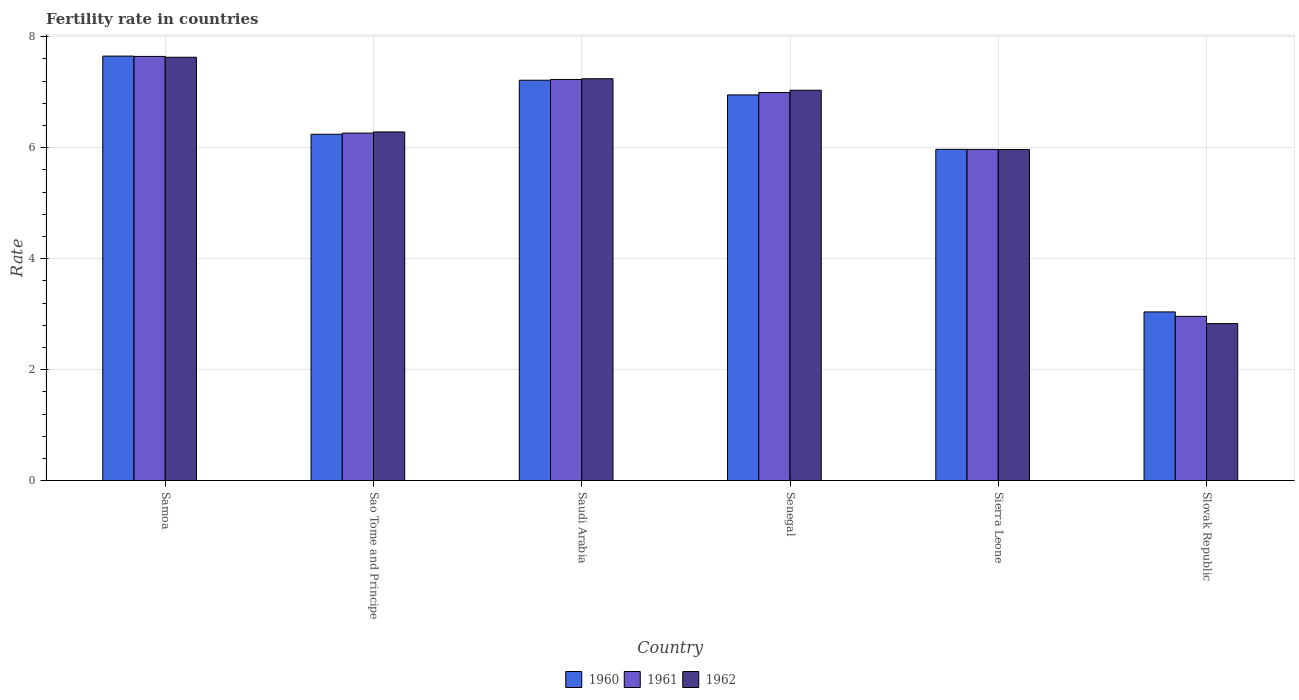Are the number of bars per tick equal to the number of legend labels?
Your answer should be very brief. Yes. Are the number of bars on each tick of the X-axis equal?
Give a very brief answer. Yes. How many bars are there on the 4th tick from the left?
Provide a short and direct response. 3. How many bars are there on the 3rd tick from the right?
Ensure brevity in your answer.  3. What is the label of the 2nd group of bars from the left?
Offer a terse response. Sao Tome and Principe. In how many cases, is the number of bars for a given country not equal to the number of legend labels?
Offer a very short reply. 0. What is the fertility rate in 1961 in Senegal?
Make the answer very short. 6.99. Across all countries, what is the maximum fertility rate in 1962?
Give a very brief answer. 7.63. Across all countries, what is the minimum fertility rate in 1960?
Offer a very short reply. 3.04. In which country was the fertility rate in 1960 maximum?
Your response must be concise. Samoa. In which country was the fertility rate in 1961 minimum?
Your response must be concise. Slovak Republic. What is the total fertility rate in 1962 in the graph?
Provide a succinct answer. 36.99. What is the difference between the fertility rate in 1961 in Saudi Arabia and that in Slovak Republic?
Make the answer very short. 4.27. What is the difference between the fertility rate in 1962 in Sierra Leone and the fertility rate in 1960 in Slovak Republic?
Your answer should be compact. 2.93. What is the average fertility rate in 1961 per country?
Provide a short and direct response. 6.18. What is the difference between the fertility rate of/in 1960 and fertility rate of/in 1962 in Senegal?
Make the answer very short. -0.08. What is the ratio of the fertility rate in 1961 in Sao Tome and Principe to that in Slovak Republic?
Your answer should be very brief. 2.12. What is the difference between the highest and the second highest fertility rate in 1960?
Your answer should be compact. 0.26. In how many countries, is the fertility rate in 1961 greater than the average fertility rate in 1961 taken over all countries?
Offer a terse response. 4. Is the sum of the fertility rate in 1960 in Samoa and Sao Tome and Principe greater than the maximum fertility rate in 1961 across all countries?
Provide a short and direct response. Yes. What does the 2nd bar from the left in Slovak Republic represents?
Your response must be concise. 1961. What does the 3rd bar from the right in Sierra Leone represents?
Provide a succinct answer. 1960. How many bars are there?
Provide a short and direct response. 18. Are all the bars in the graph horizontal?
Offer a terse response. No. How many countries are there in the graph?
Ensure brevity in your answer.  6. Are the values on the major ticks of Y-axis written in scientific E-notation?
Offer a terse response. No. Does the graph contain any zero values?
Ensure brevity in your answer.  No. Where does the legend appear in the graph?
Give a very brief answer. Bottom center. What is the title of the graph?
Ensure brevity in your answer.  Fertility rate in countries. What is the label or title of the Y-axis?
Provide a short and direct response. Rate. What is the Rate of 1960 in Samoa?
Provide a short and direct response. 7.65. What is the Rate in 1961 in Samoa?
Your response must be concise. 7.64. What is the Rate of 1962 in Samoa?
Provide a short and direct response. 7.63. What is the Rate of 1960 in Sao Tome and Principe?
Offer a very short reply. 6.24. What is the Rate in 1961 in Sao Tome and Principe?
Keep it short and to the point. 6.26. What is the Rate of 1962 in Sao Tome and Principe?
Your answer should be very brief. 6.28. What is the Rate of 1960 in Saudi Arabia?
Your response must be concise. 7.22. What is the Rate of 1961 in Saudi Arabia?
Offer a very short reply. 7.23. What is the Rate of 1962 in Saudi Arabia?
Keep it short and to the point. 7.24. What is the Rate in 1960 in Senegal?
Your response must be concise. 6.95. What is the Rate in 1961 in Senegal?
Provide a succinct answer. 6.99. What is the Rate in 1962 in Senegal?
Provide a short and direct response. 7.04. What is the Rate of 1960 in Sierra Leone?
Your answer should be very brief. 5.97. What is the Rate of 1961 in Sierra Leone?
Provide a short and direct response. 5.97. What is the Rate of 1962 in Sierra Leone?
Your answer should be compact. 5.97. What is the Rate in 1960 in Slovak Republic?
Your answer should be compact. 3.04. What is the Rate of 1961 in Slovak Republic?
Make the answer very short. 2.96. What is the Rate of 1962 in Slovak Republic?
Offer a terse response. 2.83. Across all countries, what is the maximum Rate of 1960?
Make the answer very short. 7.65. Across all countries, what is the maximum Rate of 1961?
Your answer should be compact. 7.64. Across all countries, what is the maximum Rate of 1962?
Keep it short and to the point. 7.63. Across all countries, what is the minimum Rate of 1960?
Your response must be concise. 3.04. Across all countries, what is the minimum Rate of 1961?
Offer a terse response. 2.96. Across all countries, what is the minimum Rate of 1962?
Your response must be concise. 2.83. What is the total Rate in 1960 in the graph?
Offer a terse response. 37.07. What is the total Rate in 1961 in the graph?
Give a very brief answer. 37.06. What is the total Rate of 1962 in the graph?
Your answer should be compact. 36.99. What is the difference between the Rate of 1960 in Samoa and that in Sao Tome and Principe?
Provide a succinct answer. 1.41. What is the difference between the Rate in 1961 in Samoa and that in Sao Tome and Principe?
Keep it short and to the point. 1.38. What is the difference between the Rate in 1962 in Samoa and that in Sao Tome and Principe?
Provide a short and direct response. 1.35. What is the difference between the Rate of 1960 in Samoa and that in Saudi Arabia?
Your answer should be compact. 0.43. What is the difference between the Rate in 1961 in Samoa and that in Saudi Arabia?
Offer a terse response. 0.41. What is the difference between the Rate of 1962 in Samoa and that in Saudi Arabia?
Make the answer very short. 0.39. What is the difference between the Rate of 1960 in Samoa and that in Senegal?
Your answer should be compact. 0.7. What is the difference between the Rate of 1961 in Samoa and that in Senegal?
Your response must be concise. 0.65. What is the difference between the Rate of 1962 in Samoa and that in Senegal?
Offer a very short reply. 0.59. What is the difference between the Rate of 1960 in Samoa and that in Sierra Leone?
Give a very brief answer. 1.68. What is the difference between the Rate of 1961 in Samoa and that in Sierra Leone?
Your response must be concise. 1.68. What is the difference between the Rate of 1962 in Samoa and that in Sierra Leone?
Give a very brief answer. 1.66. What is the difference between the Rate in 1960 in Samoa and that in Slovak Republic?
Make the answer very short. 4.61. What is the difference between the Rate of 1961 in Samoa and that in Slovak Republic?
Give a very brief answer. 4.68. What is the difference between the Rate of 1960 in Sao Tome and Principe and that in Saudi Arabia?
Your answer should be compact. -0.97. What is the difference between the Rate of 1961 in Sao Tome and Principe and that in Saudi Arabia?
Keep it short and to the point. -0.97. What is the difference between the Rate in 1962 in Sao Tome and Principe and that in Saudi Arabia?
Your response must be concise. -0.96. What is the difference between the Rate of 1960 in Sao Tome and Principe and that in Senegal?
Your answer should be compact. -0.71. What is the difference between the Rate of 1961 in Sao Tome and Principe and that in Senegal?
Make the answer very short. -0.73. What is the difference between the Rate of 1962 in Sao Tome and Principe and that in Senegal?
Your answer should be very brief. -0.75. What is the difference between the Rate in 1960 in Sao Tome and Principe and that in Sierra Leone?
Offer a terse response. 0.27. What is the difference between the Rate in 1961 in Sao Tome and Principe and that in Sierra Leone?
Give a very brief answer. 0.29. What is the difference between the Rate of 1962 in Sao Tome and Principe and that in Sierra Leone?
Make the answer very short. 0.32. What is the difference between the Rate of 1960 in Sao Tome and Principe and that in Slovak Republic?
Give a very brief answer. 3.2. What is the difference between the Rate of 1961 in Sao Tome and Principe and that in Slovak Republic?
Your answer should be very brief. 3.3. What is the difference between the Rate in 1962 in Sao Tome and Principe and that in Slovak Republic?
Your answer should be very brief. 3.45. What is the difference between the Rate of 1960 in Saudi Arabia and that in Senegal?
Provide a short and direct response. 0.27. What is the difference between the Rate of 1961 in Saudi Arabia and that in Senegal?
Your answer should be very brief. 0.24. What is the difference between the Rate in 1962 in Saudi Arabia and that in Senegal?
Ensure brevity in your answer.  0.21. What is the difference between the Rate in 1960 in Saudi Arabia and that in Sierra Leone?
Your response must be concise. 1.25. What is the difference between the Rate of 1961 in Saudi Arabia and that in Sierra Leone?
Your answer should be very brief. 1.26. What is the difference between the Rate in 1962 in Saudi Arabia and that in Sierra Leone?
Give a very brief answer. 1.28. What is the difference between the Rate in 1960 in Saudi Arabia and that in Slovak Republic?
Give a very brief answer. 4.18. What is the difference between the Rate in 1961 in Saudi Arabia and that in Slovak Republic?
Give a very brief answer. 4.27. What is the difference between the Rate of 1962 in Saudi Arabia and that in Slovak Republic?
Your answer should be compact. 4.41. What is the difference between the Rate in 1961 in Senegal and that in Sierra Leone?
Provide a short and direct response. 1.02. What is the difference between the Rate in 1962 in Senegal and that in Sierra Leone?
Offer a terse response. 1.07. What is the difference between the Rate in 1960 in Senegal and that in Slovak Republic?
Your answer should be very brief. 3.91. What is the difference between the Rate in 1961 in Senegal and that in Slovak Republic?
Keep it short and to the point. 4.03. What is the difference between the Rate in 1962 in Senegal and that in Slovak Republic?
Your response must be concise. 4.21. What is the difference between the Rate in 1960 in Sierra Leone and that in Slovak Republic?
Provide a short and direct response. 2.93. What is the difference between the Rate in 1961 in Sierra Leone and that in Slovak Republic?
Offer a very short reply. 3.01. What is the difference between the Rate of 1962 in Sierra Leone and that in Slovak Republic?
Offer a terse response. 3.14. What is the difference between the Rate of 1960 in Samoa and the Rate of 1961 in Sao Tome and Principe?
Keep it short and to the point. 1.39. What is the difference between the Rate in 1960 in Samoa and the Rate in 1962 in Sao Tome and Principe?
Ensure brevity in your answer.  1.37. What is the difference between the Rate of 1961 in Samoa and the Rate of 1962 in Sao Tome and Principe?
Offer a terse response. 1.36. What is the difference between the Rate in 1960 in Samoa and the Rate in 1961 in Saudi Arabia?
Provide a succinct answer. 0.42. What is the difference between the Rate in 1960 in Samoa and the Rate in 1962 in Saudi Arabia?
Provide a short and direct response. 0.41. What is the difference between the Rate in 1961 in Samoa and the Rate in 1962 in Saudi Arabia?
Make the answer very short. 0.4. What is the difference between the Rate of 1960 in Samoa and the Rate of 1961 in Senegal?
Your answer should be compact. 0.66. What is the difference between the Rate of 1960 in Samoa and the Rate of 1962 in Senegal?
Your response must be concise. 0.61. What is the difference between the Rate of 1961 in Samoa and the Rate of 1962 in Senegal?
Your answer should be very brief. 0.61. What is the difference between the Rate of 1960 in Samoa and the Rate of 1961 in Sierra Leone?
Your answer should be compact. 1.68. What is the difference between the Rate in 1960 in Samoa and the Rate in 1962 in Sierra Leone?
Provide a short and direct response. 1.68. What is the difference between the Rate in 1961 in Samoa and the Rate in 1962 in Sierra Leone?
Provide a succinct answer. 1.68. What is the difference between the Rate of 1960 in Samoa and the Rate of 1961 in Slovak Republic?
Provide a succinct answer. 4.69. What is the difference between the Rate in 1960 in Samoa and the Rate in 1962 in Slovak Republic?
Keep it short and to the point. 4.82. What is the difference between the Rate in 1961 in Samoa and the Rate in 1962 in Slovak Republic?
Offer a very short reply. 4.82. What is the difference between the Rate of 1960 in Sao Tome and Principe and the Rate of 1961 in Saudi Arabia?
Keep it short and to the point. -0.99. What is the difference between the Rate in 1960 in Sao Tome and Principe and the Rate in 1962 in Saudi Arabia?
Offer a very short reply. -1. What is the difference between the Rate in 1961 in Sao Tome and Principe and the Rate in 1962 in Saudi Arabia?
Your response must be concise. -0.98. What is the difference between the Rate in 1960 in Sao Tome and Principe and the Rate in 1961 in Senegal?
Your response must be concise. -0.75. What is the difference between the Rate in 1960 in Sao Tome and Principe and the Rate in 1962 in Senegal?
Your answer should be compact. -0.79. What is the difference between the Rate in 1961 in Sao Tome and Principe and the Rate in 1962 in Senegal?
Give a very brief answer. -0.77. What is the difference between the Rate in 1960 in Sao Tome and Principe and the Rate in 1961 in Sierra Leone?
Your answer should be compact. 0.27. What is the difference between the Rate in 1960 in Sao Tome and Principe and the Rate in 1962 in Sierra Leone?
Ensure brevity in your answer.  0.28. What is the difference between the Rate in 1961 in Sao Tome and Principe and the Rate in 1962 in Sierra Leone?
Your answer should be very brief. 0.3. What is the difference between the Rate in 1960 in Sao Tome and Principe and the Rate in 1961 in Slovak Republic?
Offer a terse response. 3.28. What is the difference between the Rate in 1960 in Sao Tome and Principe and the Rate in 1962 in Slovak Republic?
Your answer should be compact. 3.41. What is the difference between the Rate of 1961 in Sao Tome and Principe and the Rate of 1962 in Slovak Republic?
Provide a short and direct response. 3.43. What is the difference between the Rate in 1960 in Saudi Arabia and the Rate in 1961 in Senegal?
Provide a short and direct response. 0.22. What is the difference between the Rate in 1960 in Saudi Arabia and the Rate in 1962 in Senegal?
Your answer should be very brief. 0.18. What is the difference between the Rate of 1961 in Saudi Arabia and the Rate of 1962 in Senegal?
Your answer should be compact. 0.19. What is the difference between the Rate of 1960 in Saudi Arabia and the Rate of 1961 in Sierra Leone?
Make the answer very short. 1.25. What is the difference between the Rate of 1960 in Saudi Arabia and the Rate of 1962 in Sierra Leone?
Make the answer very short. 1.25. What is the difference between the Rate in 1961 in Saudi Arabia and the Rate in 1962 in Sierra Leone?
Your answer should be compact. 1.26. What is the difference between the Rate of 1960 in Saudi Arabia and the Rate of 1961 in Slovak Republic?
Your answer should be very brief. 4.26. What is the difference between the Rate in 1960 in Saudi Arabia and the Rate in 1962 in Slovak Republic?
Your answer should be compact. 4.39. What is the difference between the Rate in 1960 in Senegal and the Rate in 1962 in Sierra Leone?
Offer a terse response. 0.98. What is the difference between the Rate in 1960 in Senegal and the Rate in 1961 in Slovak Republic?
Keep it short and to the point. 3.99. What is the difference between the Rate in 1960 in Senegal and the Rate in 1962 in Slovak Republic?
Provide a short and direct response. 4.12. What is the difference between the Rate of 1961 in Senegal and the Rate of 1962 in Slovak Republic?
Your answer should be compact. 4.16. What is the difference between the Rate of 1960 in Sierra Leone and the Rate of 1961 in Slovak Republic?
Offer a very short reply. 3.01. What is the difference between the Rate of 1960 in Sierra Leone and the Rate of 1962 in Slovak Republic?
Make the answer very short. 3.14. What is the difference between the Rate in 1961 in Sierra Leone and the Rate in 1962 in Slovak Republic?
Keep it short and to the point. 3.14. What is the average Rate in 1960 per country?
Make the answer very short. 6.18. What is the average Rate of 1961 per country?
Your answer should be compact. 6.18. What is the average Rate in 1962 per country?
Your answer should be very brief. 6.17. What is the difference between the Rate of 1960 and Rate of 1961 in Samoa?
Your response must be concise. 0.01. What is the difference between the Rate of 1960 and Rate of 1962 in Samoa?
Your answer should be very brief. 0.02. What is the difference between the Rate in 1961 and Rate in 1962 in Samoa?
Provide a succinct answer. 0.01. What is the difference between the Rate of 1960 and Rate of 1961 in Sao Tome and Principe?
Make the answer very short. -0.02. What is the difference between the Rate in 1960 and Rate in 1962 in Sao Tome and Principe?
Your answer should be compact. -0.04. What is the difference between the Rate of 1961 and Rate of 1962 in Sao Tome and Principe?
Provide a short and direct response. -0.02. What is the difference between the Rate of 1960 and Rate of 1961 in Saudi Arabia?
Make the answer very short. -0.01. What is the difference between the Rate of 1960 and Rate of 1962 in Saudi Arabia?
Your answer should be compact. -0.03. What is the difference between the Rate in 1961 and Rate in 1962 in Saudi Arabia?
Give a very brief answer. -0.01. What is the difference between the Rate of 1960 and Rate of 1961 in Senegal?
Your response must be concise. -0.04. What is the difference between the Rate of 1960 and Rate of 1962 in Senegal?
Offer a very short reply. -0.09. What is the difference between the Rate of 1961 and Rate of 1962 in Senegal?
Offer a very short reply. -0.04. What is the difference between the Rate in 1960 and Rate in 1962 in Sierra Leone?
Ensure brevity in your answer.  0. What is the difference between the Rate in 1961 and Rate in 1962 in Sierra Leone?
Offer a terse response. 0. What is the difference between the Rate of 1960 and Rate of 1961 in Slovak Republic?
Your answer should be very brief. 0.08. What is the difference between the Rate in 1960 and Rate in 1962 in Slovak Republic?
Offer a very short reply. 0.21. What is the difference between the Rate of 1961 and Rate of 1962 in Slovak Republic?
Keep it short and to the point. 0.13. What is the ratio of the Rate in 1960 in Samoa to that in Sao Tome and Principe?
Offer a very short reply. 1.23. What is the ratio of the Rate in 1961 in Samoa to that in Sao Tome and Principe?
Provide a succinct answer. 1.22. What is the ratio of the Rate in 1962 in Samoa to that in Sao Tome and Principe?
Provide a short and direct response. 1.21. What is the ratio of the Rate in 1960 in Samoa to that in Saudi Arabia?
Give a very brief answer. 1.06. What is the ratio of the Rate of 1961 in Samoa to that in Saudi Arabia?
Your response must be concise. 1.06. What is the ratio of the Rate of 1962 in Samoa to that in Saudi Arabia?
Your answer should be very brief. 1.05. What is the ratio of the Rate of 1960 in Samoa to that in Senegal?
Ensure brevity in your answer.  1.1. What is the ratio of the Rate in 1961 in Samoa to that in Senegal?
Make the answer very short. 1.09. What is the ratio of the Rate in 1962 in Samoa to that in Senegal?
Your answer should be compact. 1.08. What is the ratio of the Rate in 1960 in Samoa to that in Sierra Leone?
Provide a short and direct response. 1.28. What is the ratio of the Rate in 1961 in Samoa to that in Sierra Leone?
Provide a short and direct response. 1.28. What is the ratio of the Rate of 1962 in Samoa to that in Sierra Leone?
Provide a succinct answer. 1.28. What is the ratio of the Rate in 1960 in Samoa to that in Slovak Republic?
Make the answer very short. 2.52. What is the ratio of the Rate of 1961 in Samoa to that in Slovak Republic?
Provide a short and direct response. 2.58. What is the ratio of the Rate of 1962 in Samoa to that in Slovak Republic?
Provide a short and direct response. 2.7. What is the ratio of the Rate in 1960 in Sao Tome and Principe to that in Saudi Arabia?
Your response must be concise. 0.86. What is the ratio of the Rate of 1961 in Sao Tome and Principe to that in Saudi Arabia?
Your answer should be very brief. 0.87. What is the ratio of the Rate in 1962 in Sao Tome and Principe to that in Saudi Arabia?
Give a very brief answer. 0.87. What is the ratio of the Rate in 1960 in Sao Tome and Principe to that in Senegal?
Offer a terse response. 0.9. What is the ratio of the Rate of 1961 in Sao Tome and Principe to that in Senegal?
Keep it short and to the point. 0.9. What is the ratio of the Rate of 1962 in Sao Tome and Principe to that in Senegal?
Give a very brief answer. 0.89. What is the ratio of the Rate in 1960 in Sao Tome and Principe to that in Sierra Leone?
Provide a short and direct response. 1.05. What is the ratio of the Rate in 1961 in Sao Tome and Principe to that in Sierra Leone?
Give a very brief answer. 1.05. What is the ratio of the Rate in 1962 in Sao Tome and Principe to that in Sierra Leone?
Offer a terse response. 1.05. What is the ratio of the Rate of 1960 in Sao Tome and Principe to that in Slovak Republic?
Keep it short and to the point. 2.05. What is the ratio of the Rate of 1961 in Sao Tome and Principe to that in Slovak Republic?
Your answer should be very brief. 2.12. What is the ratio of the Rate of 1962 in Sao Tome and Principe to that in Slovak Republic?
Make the answer very short. 2.22. What is the ratio of the Rate of 1960 in Saudi Arabia to that in Senegal?
Give a very brief answer. 1.04. What is the ratio of the Rate of 1961 in Saudi Arabia to that in Senegal?
Your answer should be very brief. 1.03. What is the ratio of the Rate of 1962 in Saudi Arabia to that in Senegal?
Make the answer very short. 1.03. What is the ratio of the Rate of 1960 in Saudi Arabia to that in Sierra Leone?
Your response must be concise. 1.21. What is the ratio of the Rate in 1961 in Saudi Arabia to that in Sierra Leone?
Provide a short and direct response. 1.21. What is the ratio of the Rate in 1962 in Saudi Arabia to that in Sierra Leone?
Your response must be concise. 1.21. What is the ratio of the Rate in 1960 in Saudi Arabia to that in Slovak Republic?
Your response must be concise. 2.37. What is the ratio of the Rate of 1961 in Saudi Arabia to that in Slovak Republic?
Your answer should be very brief. 2.44. What is the ratio of the Rate in 1962 in Saudi Arabia to that in Slovak Republic?
Give a very brief answer. 2.56. What is the ratio of the Rate of 1960 in Senegal to that in Sierra Leone?
Offer a terse response. 1.16. What is the ratio of the Rate in 1961 in Senegal to that in Sierra Leone?
Provide a succinct answer. 1.17. What is the ratio of the Rate in 1962 in Senegal to that in Sierra Leone?
Provide a succinct answer. 1.18. What is the ratio of the Rate in 1960 in Senegal to that in Slovak Republic?
Provide a succinct answer. 2.29. What is the ratio of the Rate in 1961 in Senegal to that in Slovak Republic?
Your response must be concise. 2.36. What is the ratio of the Rate of 1962 in Senegal to that in Slovak Republic?
Your answer should be compact. 2.49. What is the ratio of the Rate of 1960 in Sierra Leone to that in Slovak Republic?
Give a very brief answer. 1.96. What is the ratio of the Rate of 1961 in Sierra Leone to that in Slovak Republic?
Your answer should be compact. 2.02. What is the ratio of the Rate of 1962 in Sierra Leone to that in Slovak Republic?
Your response must be concise. 2.11. What is the difference between the highest and the second highest Rate of 1960?
Your response must be concise. 0.43. What is the difference between the highest and the second highest Rate of 1961?
Offer a very short reply. 0.41. What is the difference between the highest and the second highest Rate in 1962?
Provide a succinct answer. 0.39. What is the difference between the highest and the lowest Rate of 1960?
Offer a terse response. 4.61. What is the difference between the highest and the lowest Rate of 1961?
Make the answer very short. 4.68. 